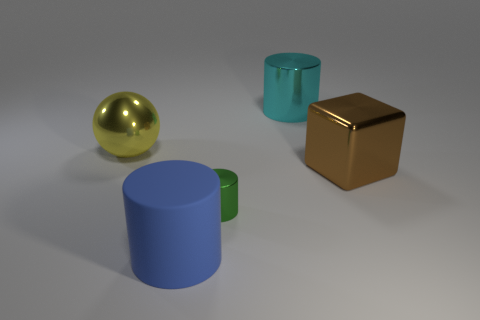Subtract all big cylinders. How many cylinders are left? 1 Subtract 1 blocks. How many blocks are left? 0 Subtract all cyan cylinders. How many cylinders are left? 2 Add 2 small red shiny cylinders. How many objects exist? 7 Subtract all cylinders. How many objects are left? 2 Subtract 1 yellow balls. How many objects are left? 4 Subtract all yellow blocks. Subtract all brown cylinders. How many blocks are left? 1 Subtract all blue blocks. How many green cylinders are left? 1 Subtract all large cylinders. Subtract all large matte things. How many objects are left? 2 Add 2 blue matte cylinders. How many blue matte cylinders are left? 3 